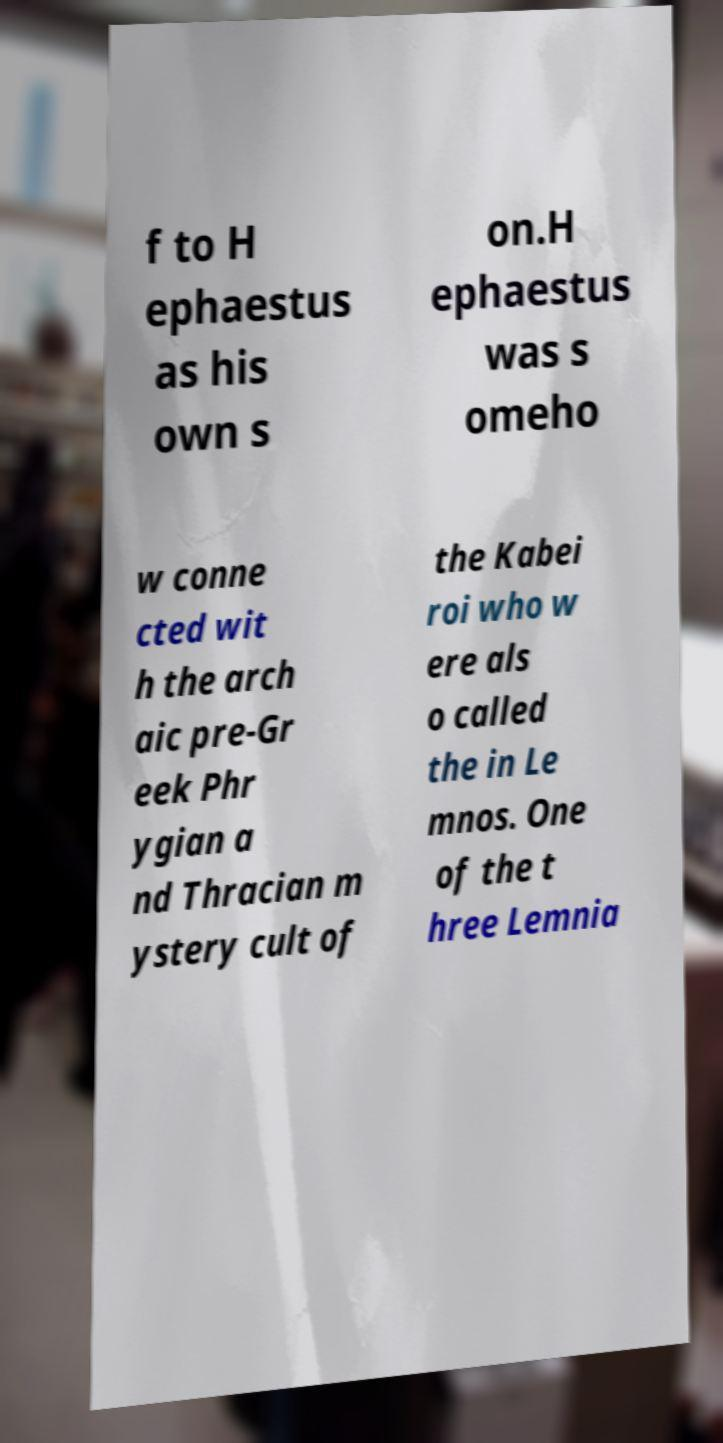What messages or text are displayed in this image? I need them in a readable, typed format. f to H ephaestus as his own s on.H ephaestus was s omeho w conne cted wit h the arch aic pre-Gr eek Phr ygian a nd Thracian m ystery cult of the Kabei roi who w ere als o called the in Le mnos. One of the t hree Lemnia 